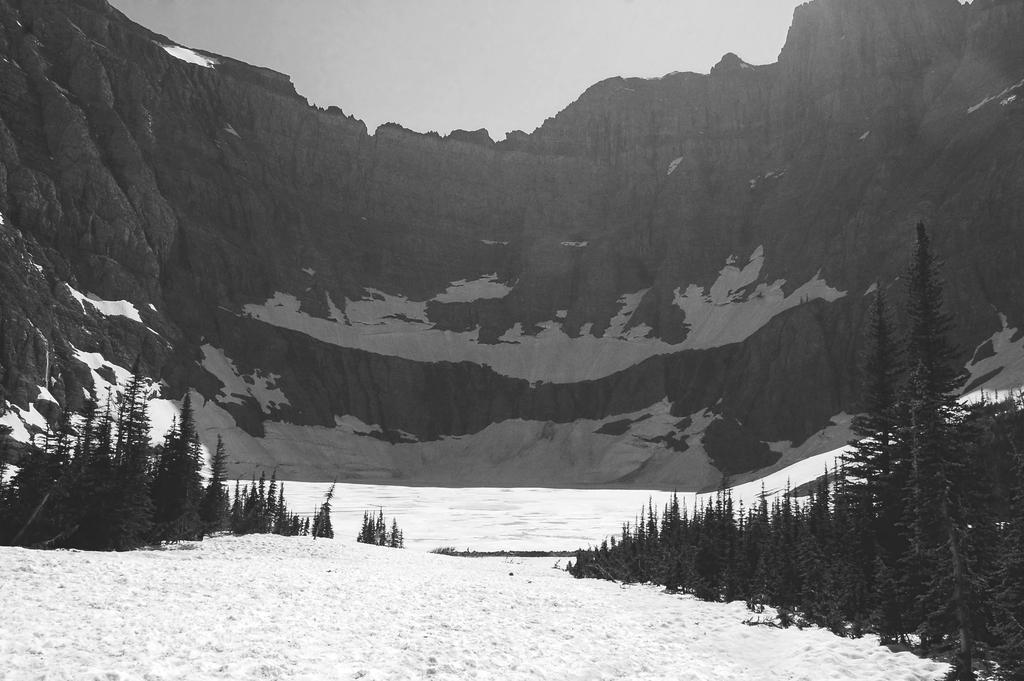What type of weather is depicted in the image? There is snow in the image, indicating cold weather. What type of vegetation can be seen in the image? There are plants and trees in the image. What is the condition of the sky in the image? The sky is clear in the image. Reasoning: Let's think step by identifying the main subjects and objects in the image based on the provided facts. We then formulate questions that focus on the characteristics of these subjects and objects, ensuring that each question can be answered definitively with the information given. We avoid yes/no questions and ensure that the language is simple and clear. Absurd Question/Answer: How does the snow turn into hot water in the image? There is no indication of hot water or any transformation in the image; it simply shows snow. Can you describe the plants joining together in the image? There is no indication of plants joining together in the image; they are separate entities. How does the snow join together to form a crib in the image? There is no indication of a crib or any formation of objects in the image; it simply shows snow.s snow. 